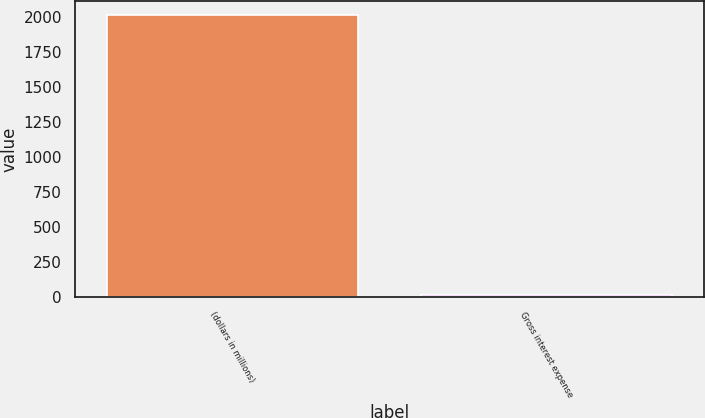<chart> <loc_0><loc_0><loc_500><loc_500><bar_chart><fcel>(dollars in millions)<fcel>Gross interest expense<nl><fcel>2012<fcel>10.5<nl></chart> 